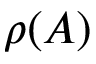<formula> <loc_0><loc_0><loc_500><loc_500>\rho ( A )</formula> 